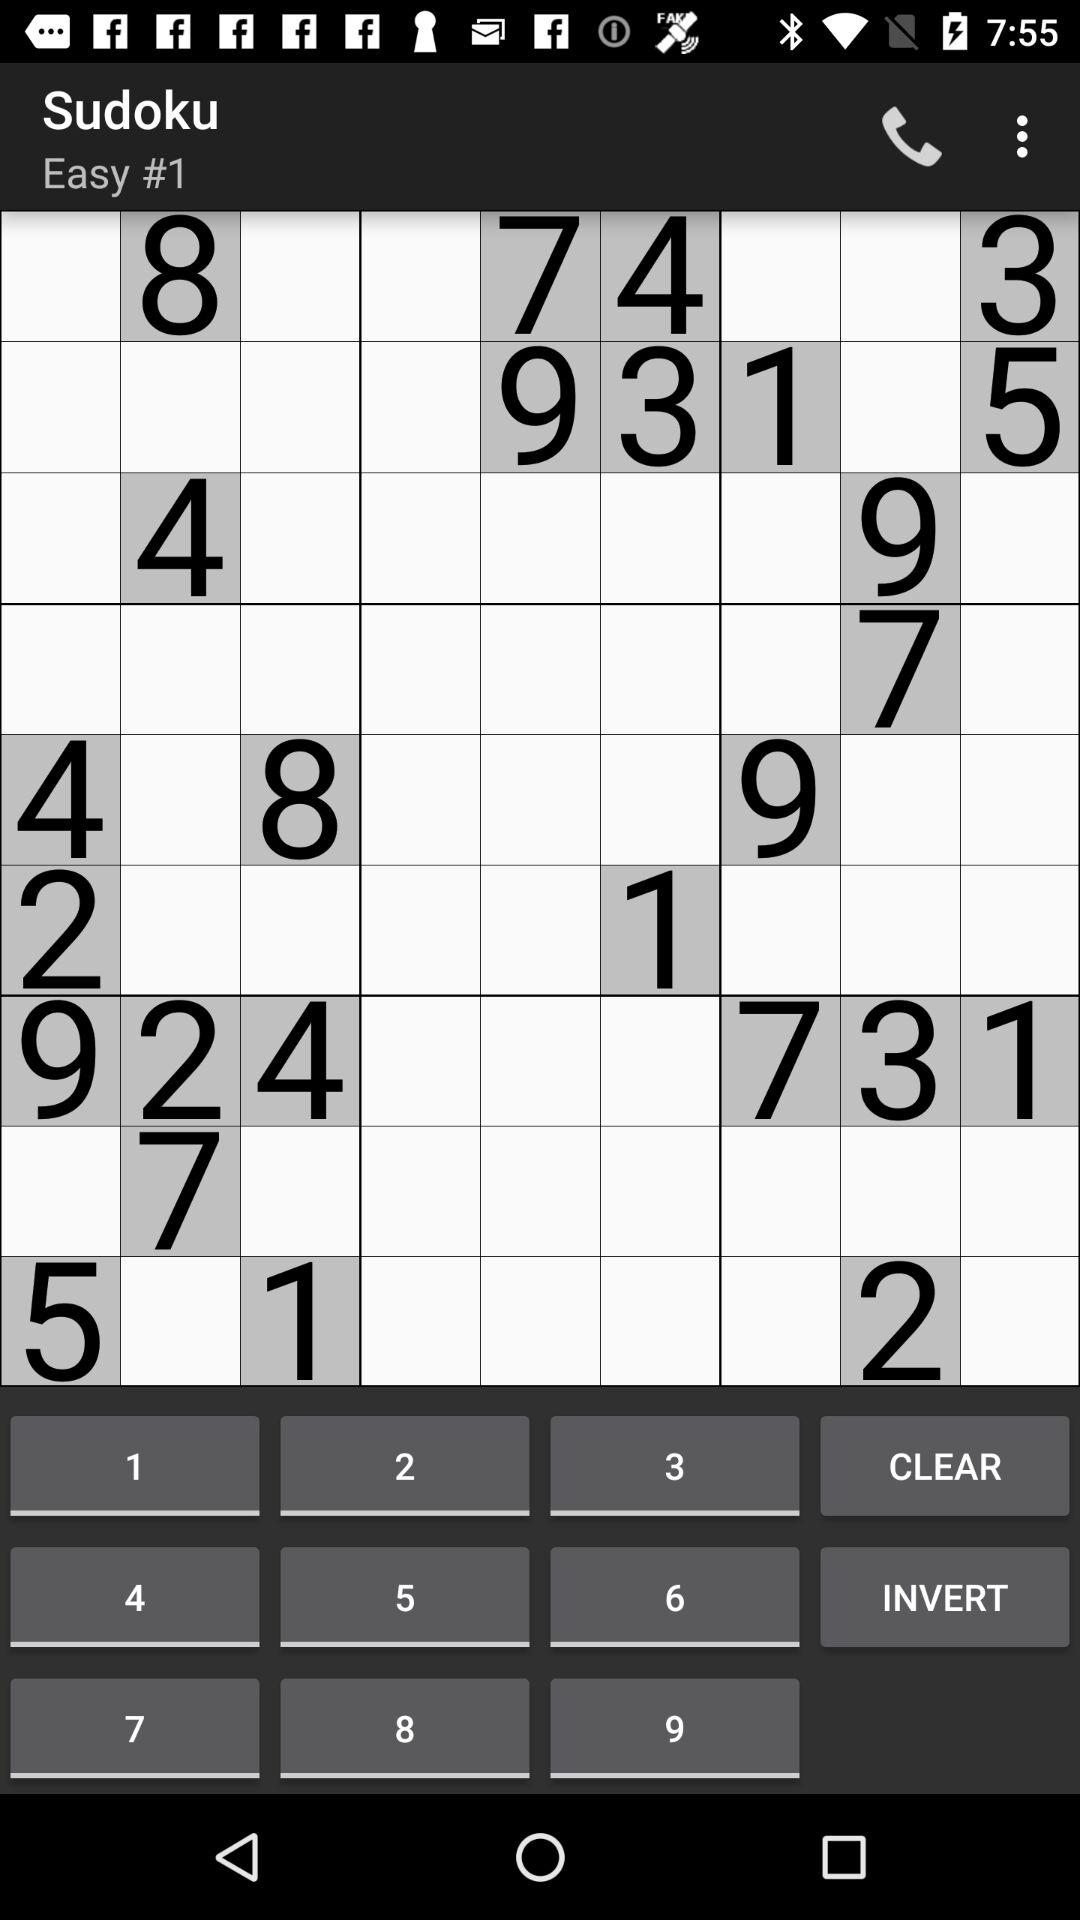Which is the current level shown on the screen? The current level shown on the screen is "Easy". 